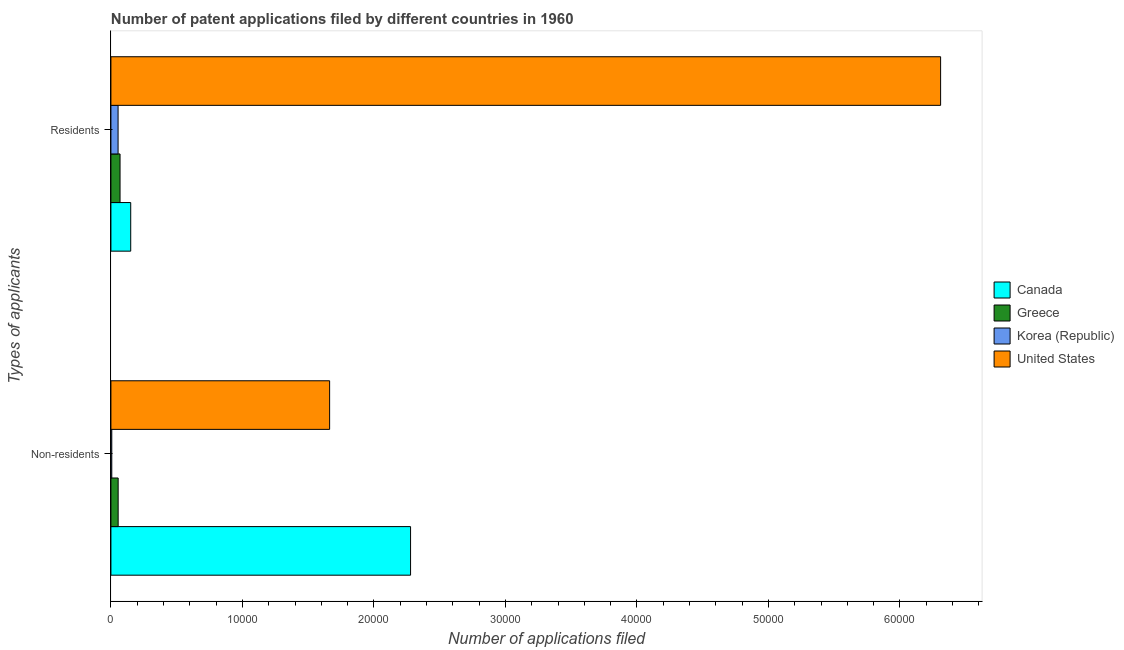Are the number of bars per tick equal to the number of legend labels?
Make the answer very short. Yes. Are the number of bars on each tick of the Y-axis equal?
Ensure brevity in your answer.  Yes. How many bars are there on the 1st tick from the top?
Offer a terse response. 4. How many bars are there on the 1st tick from the bottom?
Make the answer very short. 4. What is the label of the 1st group of bars from the top?
Make the answer very short. Residents. What is the number of patent applications by non residents in Canada?
Offer a very short reply. 2.28e+04. Across all countries, what is the maximum number of patent applications by non residents?
Offer a very short reply. 2.28e+04. Across all countries, what is the minimum number of patent applications by non residents?
Your answer should be compact. 66. What is the total number of patent applications by residents in the graph?
Your answer should be very brief. 6.58e+04. What is the difference between the number of patent applications by non residents in Canada and that in United States?
Give a very brief answer. 6155. What is the difference between the number of patent applications by non residents in Greece and the number of patent applications by residents in United States?
Provide a succinct answer. -6.25e+04. What is the average number of patent applications by non residents per country?
Offer a very short reply. 1.00e+04. What is the difference between the number of patent applications by non residents and number of patent applications by residents in United States?
Keep it short and to the point. -4.65e+04. What is the ratio of the number of patent applications by non residents in United States to that in Canada?
Ensure brevity in your answer.  0.73. Is the number of patent applications by non residents in Greece less than that in United States?
Offer a terse response. Yes. In how many countries, is the number of patent applications by non residents greater than the average number of patent applications by non residents taken over all countries?
Make the answer very short. 2. How many countries are there in the graph?
Keep it short and to the point. 4. Are the values on the major ticks of X-axis written in scientific E-notation?
Your response must be concise. No. Where does the legend appear in the graph?
Your answer should be compact. Center right. How many legend labels are there?
Ensure brevity in your answer.  4. How are the legend labels stacked?
Give a very brief answer. Vertical. What is the title of the graph?
Keep it short and to the point. Number of patent applications filed by different countries in 1960. What is the label or title of the X-axis?
Keep it short and to the point. Number of applications filed. What is the label or title of the Y-axis?
Keep it short and to the point. Types of applicants. What is the Number of applications filed in Canada in Non-residents?
Your answer should be compact. 2.28e+04. What is the Number of applications filed of Greece in Non-residents?
Offer a terse response. 551. What is the Number of applications filed in Korea (Republic) in Non-residents?
Give a very brief answer. 66. What is the Number of applications filed in United States in Non-residents?
Provide a succinct answer. 1.66e+04. What is the Number of applications filed of Canada in Residents?
Your answer should be compact. 1506. What is the Number of applications filed in Greece in Residents?
Your answer should be very brief. 694. What is the Number of applications filed of Korea (Republic) in Residents?
Ensure brevity in your answer.  545. What is the Number of applications filed in United States in Residents?
Ensure brevity in your answer.  6.31e+04. Across all Types of applicants, what is the maximum Number of applications filed of Canada?
Offer a terse response. 2.28e+04. Across all Types of applicants, what is the maximum Number of applications filed of Greece?
Ensure brevity in your answer.  694. Across all Types of applicants, what is the maximum Number of applications filed in Korea (Republic)?
Make the answer very short. 545. Across all Types of applicants, what is the maximum Number of applications filed of United States?
Provide a succinct answer. 6.31e+04. Across all Types of applicants, what is the minimum Number of applications filed in Canada?
Provide a succinct answer. 1506. Across all Types of applicants, what is the minimum Number of applications filed in Greece?
Your answer should be compact. 551. Across all Types of applicants, what is the minimum Number of applications filed in Korea (Republic)?
Give a very brief answer. 66. Across all Types of applicants, what is the minimum Number of applications filed of United States?
Your answer should be very brief. 1.66e+04. What is the total Number of applications filed in Canada in the graph?
Offer a terse response. 2.43e+04. What is the total Number of applications filed of Greece in the graph?
Make the answer very short. 1245. What is the total Number of applications filed of Korea (Republic) in the graph?
Make the answer very short. 611. What is the total Number of applications filed of United States in the graph?
Your response must be concise. 7.97e+04. What is the difference between the Number of applications filed in Canada in Non-residents and that in Residents?
Provide a short and direct response. 2.13e+04. What is the difference between the Number of applications filed of Greece in Non-residents and that in Residents?
Your answer should be compact. -143. What is the difference between the Number of applications filed of Korea (Republic) in Non-residents and that in Residents?
Your answer should be compact. -479. What is the difference between the Number of applications filed in United States in Non-residents and that in Residents?
Provide a short and direct response. -4.65e+04. What is the difference between the Number of applications filed in Canada in Non-residents and the Number of applications filed in Greece in Residents?
Provide a succinct answer. 2.21e+04. What is the difference between the Number of applications filed in Canada in Non-residents and the Number of applications filed in Korea (Republic) in Residents?
Offer a very short reply. 2.22e+04. What is the difference between the Number of applications filed in Canada in Non-residents and the Number of applications filed in United States in Residents?
Your answer should be compact. -4.03e+04. What is the difference between the Number of applications filed in Greece in Non-residents and the Number of applications filed in United States in Residents?
Your answer should be very brief. -6.25e+04. What is the difference between the Number of applications filed of Korea (Republic) in Non-residents and the Number of applications filed of United States in Residents?
Give a very brief answer. -6.30e+04. What is the average Number of applications filed in Canada per Types of applicants?
Make the answer very short. 1.21e+04. What is the average Number of applications filed of Greece per Types of applicants?
Ensure brevity in your answer.  622.5. What is the average Number of applications filed in Korea (Republic) per Types of applicants?
Provide a short and direct response. 305.5. What is the average Number of applications filed of United States per Types of applicants?
Keep it short and to the point. 3.99e+04. What is the difference between the Number of applications filed of Canada and Number of applications filed of Greece in Non-residents?
Your answer should be compact. 2.22e+04. What is the difference between the Number of applications filed in Canada and Number of applications filed in Korea (Republic) in Non-residents?
Your response must be concise. 2.27e+04. What is the difference between the Number of applications filed of Canada and Number of applications filed of United States in Non-residents?
Offer a terse response. 6155. What is the difference between the Number of applications filed in Greece and Number of applications filed in Korea (Republic) in Non-residents?
Offer a terse response. 485. What is the difference between the Number of applications filed of Greece and Number of applications filed of United States in Non-residents?
Your response must be concise. -1.61e+04. What is the difference between the Number of applications filed in Korea (Republic) and Number of applications filed in United States in Non-residents?
Keep it short and to the point. -1.66e+04. What is the difference between the Number of applications filed of Canada and Number of applications filed of Greece in Residents?
Your answer should be compact. 812. What is the difference between the Number of applications filed in Canada and Number of applications filed in Korea (Republic) in Residents?
Your answer should be very brief. 961. What is the difference between the Number of applications filed of Canada and Number of applications filed of United States in Residents?
Keep it short and to the point. -6.16e+04. What is the difference between the Number of applications filed in Greece and Number of applications filed in Korea (Republic) in Residents?
Offer a terse response. 149. What is the difference between the Number of applications filed of Greece and Number of applications filed of United States in Residents?
Provide a succinct answer. -6.24e+04. What is the difference between the Number of applications filed of Korea (Republic) and Number of applications filed of United States in Residents?
Your response must be concise. -6.25e+04. What is the ratio of the Number of applications filed of Canada in Non-residents to that in Residents?
Make the answer very short. 15.13. What is the ratio of the Number of applications filed in Greece in Non-residents to that in Residents?
Your response must be concise. 0.79. What is the ratio of the Number of applications filed in Korea (Republic) in Non-residents to that in Residents?
Your answer should be compact. 0.12. What is the ratio of the Number of applications filed of United States in Non-residents to that in Residents?
Make the answer very short. 0.26. What is the difference between the highest and the second highest Number of applications filed in Canada?
Provide a succinct answer. 2.13e+04. What is the difference between the highest and the second highest Number of applications filed of Greece?
Make the answer very short. 143. What is the difference between the highest and the second highest Number of applications filed of Korea (Republic)?
Offer a very short reply. 479. What is the difference between the highest and the second highest Number of applications filed in United States?
Offer a very short reply. 4.65e+04. What is the difference between the highest and the lowest Number of applications filed of Canada?
Offer a very short reply. 2.13e+04. What is the difference between the highest and the lowest Number of applications filed of Greece?
Ensure brevity in your answer.  143. What is the difference between the highest and the lowest Number of applications filed of Korea (Republic)?
Your answer should be very brief. 479. What is the difference between the highest and the lowest Number of applications filed in United States?
Keep it short and to the point. 4.65e+04. 